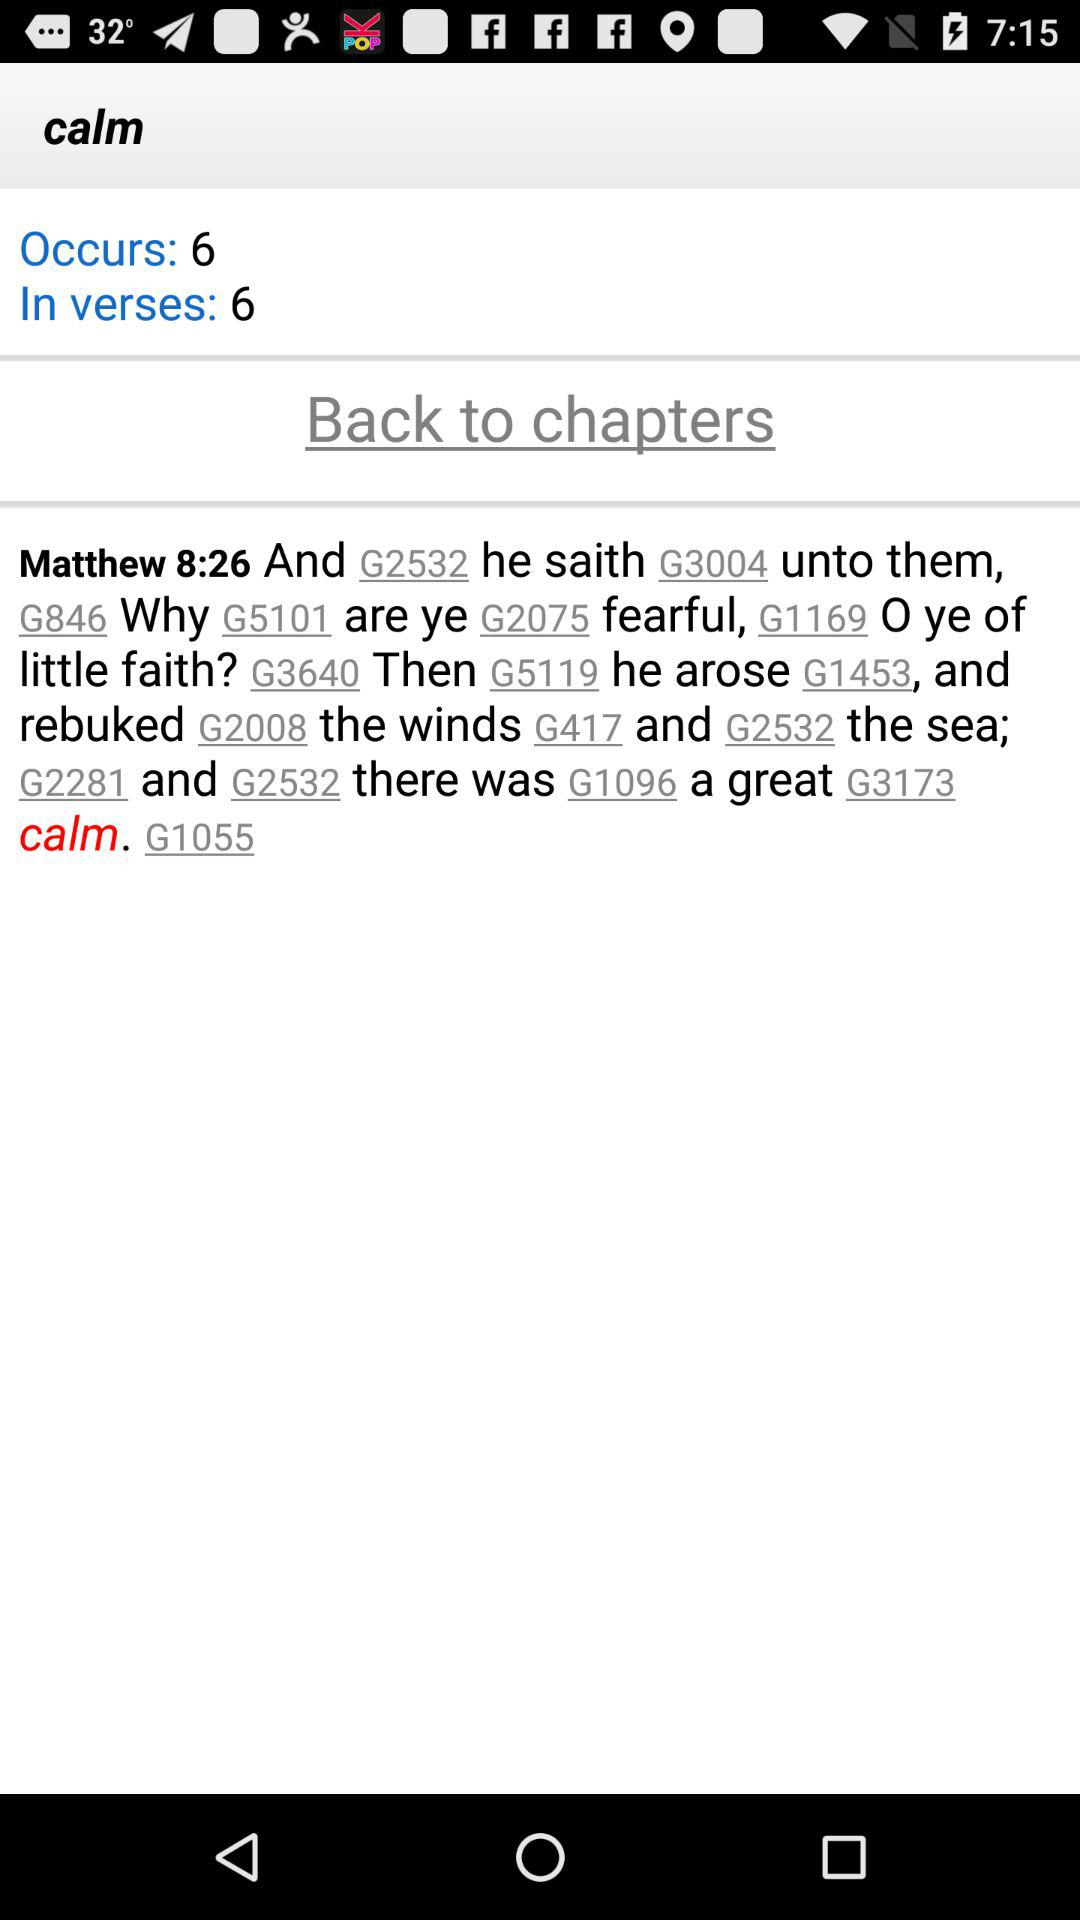What is the count of "In verses"? The count of "In verses" is 6. 